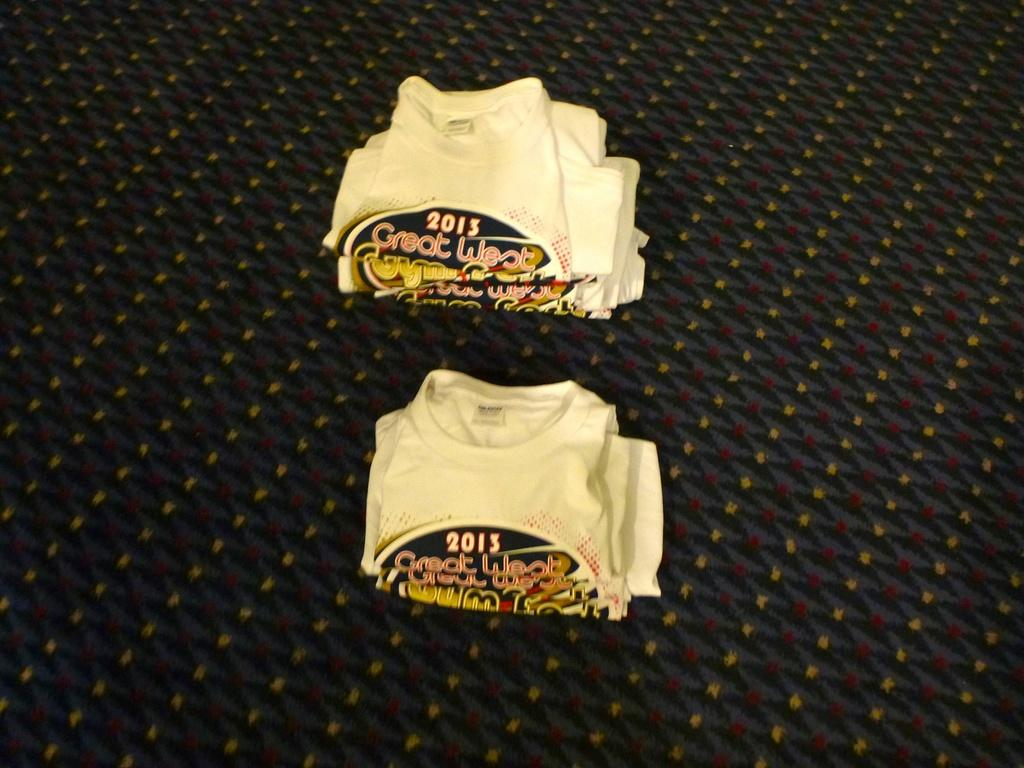Provide a one-sentence caption for the provided image. Two stacks of folded t-shirts from 2013 are sitting next to each other. 